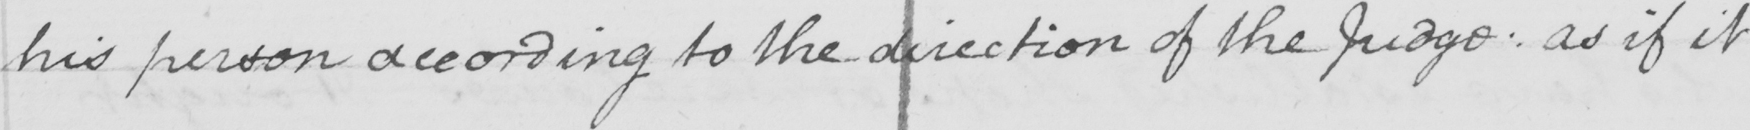Can you read and transcribe this handwriting? his person according to the direction of the Judge :  as if it 